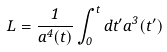Convert formula to latex. <formula><loc_0><loc_0><loc_500><loc_500>L = \frac { 1 } { a ^ { 4 } ( t ) } \int _ { 0 } ^ { t } d t ^ { \prime } a ^ { 3 } ( t ^ { \prime } )</formula> 